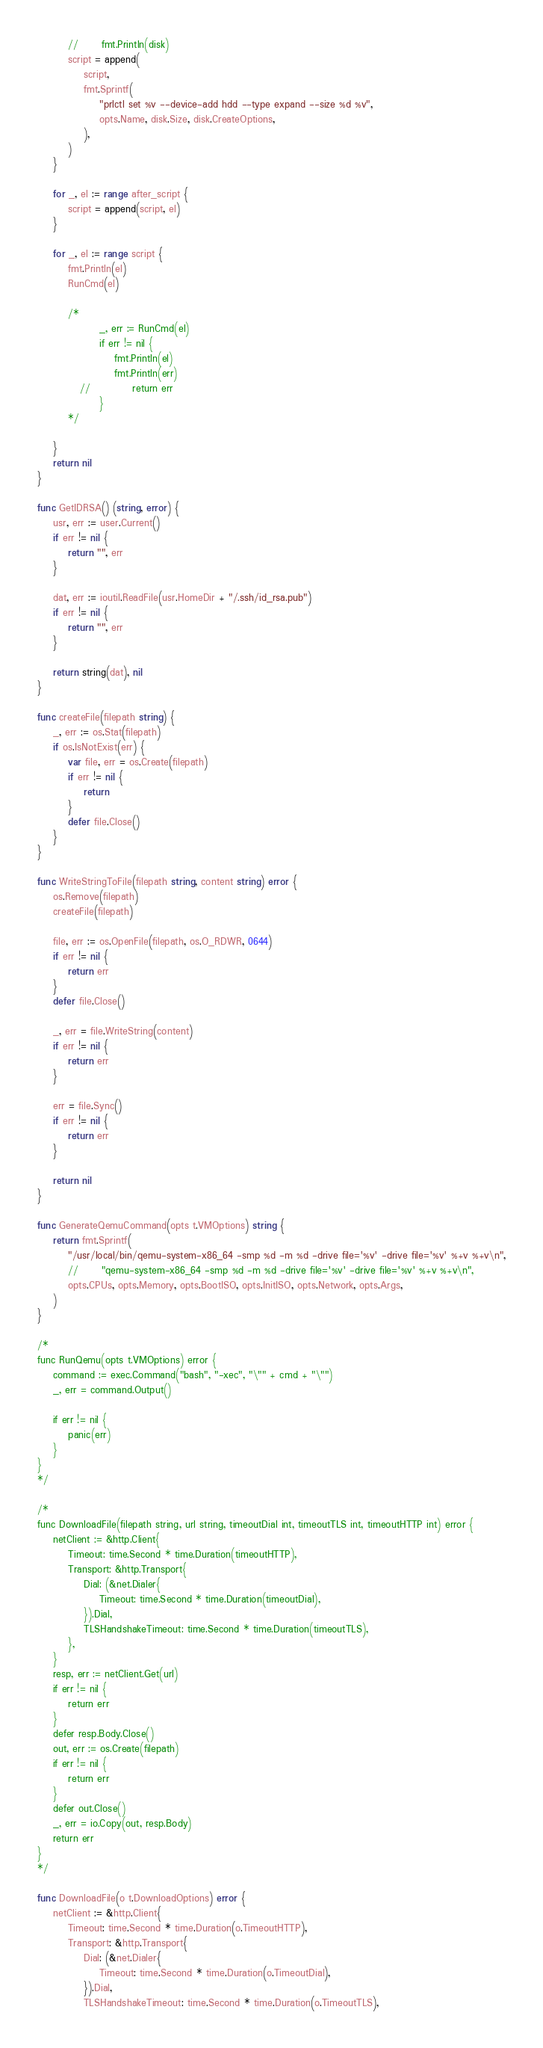<code> <loc_0><loc_0><loc_500><loc_500><_Go_>		//   	fmt.Println(disk)
		script = append(
			script,
			fmt.Sprintf(
				"prlctl set %v --device-add hdd --type expand --size %d %v",
				opts.Name, disk.Size, disk.CreateOptions,
			),
		)
	}

	for _, el := range after_script {
		script = append(script, el)
	}

	for _, el := range script {
		fmt.Println(el)
		RunCmd(el)

		/*
		   		_, err := RunCmd(el)
		   		if err != nil {
		   			fmt.Println(el)
		   			fmt.Println(err)
		   // 			return err
		   		}
		*/

	}
	return nil
}

func GetIDRSA() (string, error) {
	usr, err := user.Current()
	if err != nil {
		return "", err
	}

	dat, err := ioutil.ReadFile(usr.HomeDir + "/.ssh/id_rsa.pub")
	if err != nil {
		return "", err
	}

	return string(dat), nil
}

func createFile(filepath string) {
	_, err := os.Stat(filepath)
	if os.IsNotExist(err) {
		var file, err = os.Create(filepath)
		if err != nil {
			return
		}
		defer file.Close()
	}
}

func WriteStringToFile(filepath string, content string) error {
	os.Remove(filepath)
	createFile(filepath)

	file, err := os.OpenFile(filepath, os.O_RDWR, 0644)
	if err != nil {
		return err
	}
	defer file.Close()

	_, err = file.WriteString(content)
	if err != nil {
		return err
	}

	err = file.Sync()
	if err != nil {
		return err
	}

	return nil
}

func GenerateQemuCommand(opts t.VMOptions) string {
	return fmt.Sprintf(
		"/usr/local/bin/qemu-system-x86_64 -smp %d -m %d -drive file='%v' -drive file='%v' %+v %+v\n",
		// 		"qemu-system-x86_64 -smp %d -m %d -drive file='%v' -drive file='%v' %+v %+v\n",
		opts.CPUs, opts.Memory, opts.BootISO, opts.InitISO, opts.Network, opts.Args,
	)
}

/*
func RunQemu(opts t.VMOptions) error {
	command := exec.Command("bash", "-xec", "\"" + cmd + "\"")
	_, err = command.Output()

	if err != nil {
		panic(err)
	}
}
*/

/*
func DownloadFile(filepath string, url string, timeoutDial int, timeoutTLS int, timeoutHTTP int) error {
	netClient := &http.Client{
		Timeout: time.Second * time.Duration(timeoutHTTP),
		Transport: &http.Transport{
			Dial: (&net.Dialer{
				Timeout: time.Second * time.Duration(timeoutDial),
			}).Dial,
			TLSHandshakeTimeout: time.Second * time.Duration(timeoutTLS),
		},
	}
	resp, err := netClient.Get(url)
	if err != nil {
		return err
	}
	defer resp.Body.Close()
	out, err := os.Create(filepath)
	if err != nil {
		return err
	}
	defer out.Close()
	_, err = io.Copy(out, resp.Body)
	return err
}
*/

func DownloadFile(o t.DownloadOptions) error {
	netClient := &http.Client{
		Timeout: time.Second * time.Duration(o.TimeoutHTTP),
		Transport: &http.Transport{
			Dial: (&net.Dialer{
				Timeout: time.Second * time.Duration(o.TimeoutDial),
			}).Dial,
			TLSHandshakeTimeout: time.Second * time.Duration(o.TimeoutTLS),</code> 